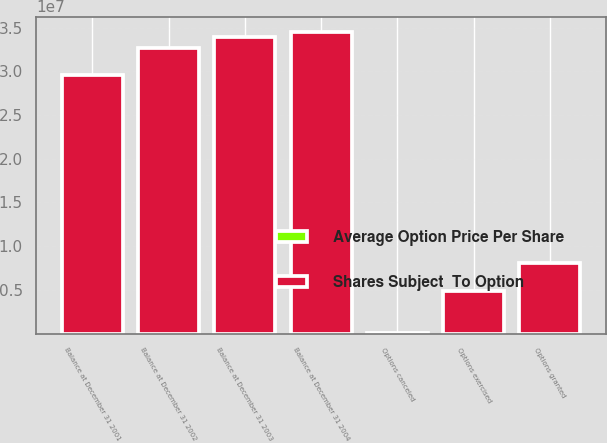Convert chart. <chart><loc_0><loc_0><loc_500><loc_500><stacked_bar_chart><ecel><fcel>Balance at December 31 2001<fcel>Options granted<fcel>Options canceled<fcel>Options exercised<fcel>Balance at December 31 2002<fcel>Balance at December 31 2003<fcel>Balance at December 31 2004<nl><fcel>Shares Subject  To Option<fcel>2.96309e+07<fcel>8.0405e+06<fcel>104212<fcel>4.89235e+06<fcel>3.26748e+07<fcel>3.39335e+07<fcel>3.45353e+07<nl><fcel>Average Option Price Per Share<fcel>17.46<fcel>25.28<fcel>19.64<fcel>15.16<fcel>19.72<fcel>21.97<fcel>24.27<nl></chart> 